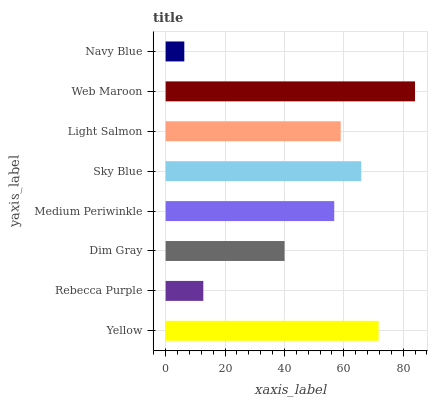Is Navy Blue the minimum?
Answer yes or no. Yes. Is Web Maroon the maximum?
Answer yes or no. Yes. Is Rebecca Purple the minimum?
Answer yes or no. No. Is Rebecca Purple the maximum?
Answer yes or no. No. Is Yellow greater than Rebecca Purple?
Answer yes or no. Yes. Is Rebecca Purple less than Yellow?
Answer yes or no. Yes. Is Rebecca Purple greater than Yellow?
Answer yes or no. No. Is Yellow less than Rebecca Purple?
Answer yes or no. No. Is Light Salmon the high median?
Answer yes or no. Yes. Is Medium Periwinkle the low median?
Answer yes or no. Yes. Is Rebecca Purple the high median?
Answer yes or no. No. Is Navy Blue the low median?
Answer yes or no. No. 